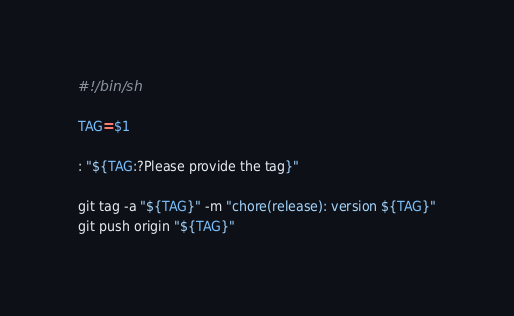<code> <loc_0><loc_0><loc_500><loc_500><_Bash_>#!/bin/sh

TAG=$1

: "${TAG:?Please provide the tag}"

git tag -a "${TAG}" -m "chore(release): version ${TAG}"
git push origin "${TAG}"
</code> 